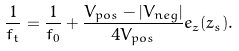<formula> <loc_0><loc_0><loc_500><loc_500>\frac { 1 } { f _ { t } } = \frac { 1 } { f _ { 0 } } + \frac { V _ { p o s } - | V _ { n e g } | } { 4 V _ { p o s } } e _ { z } ( z _ { s } ) .</formula> 